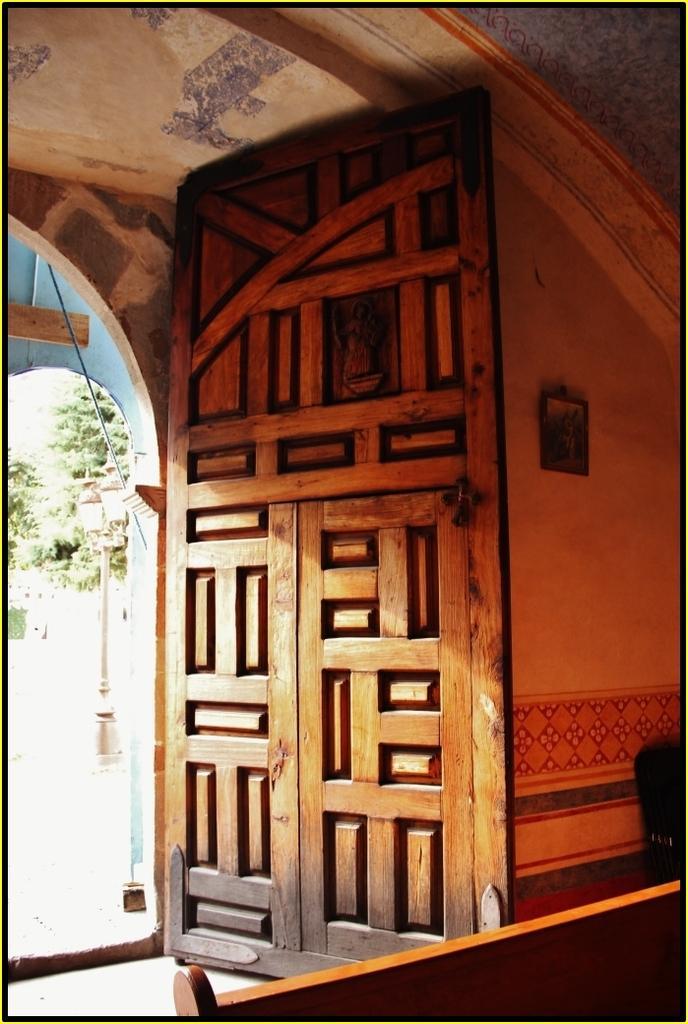Describe this image in one or two sentences. In this image in the front there is a wooden partition. In the center there is a door and on the right side there is a wall, on the wall there is a frame and in the background there is a pole and there are trees. 